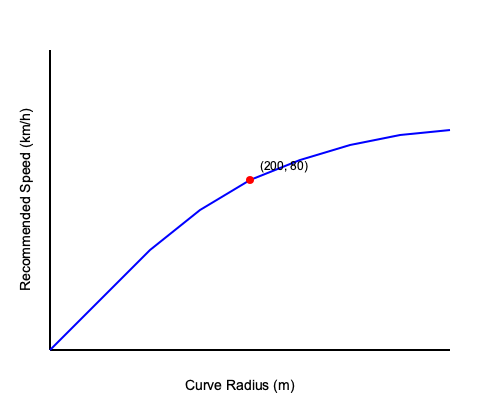Based on the graph showing the relationship between curve radius and recommended speed, what is the approximate recommended speed for a curve with a radius of 200 meters? How does this relationship demonstrate the importance of adjusting speed for different road curvatures, and what implications does this have for a professional driver focused on traffic safety? To answer this question, we need to analyze the graph and understand the relationship between curve radius and recommended speed. Let's break it down step-by-step:

1. Locate the point on the x-axis (Curve Radius) corresponding to 200 meters.
2. From this point, move vertically up to the curve on the graph.
3. The y-coordinate of this point gives us the recommended speed.
4. We can see that the point (200, 80) is marked on the graph, indicating that for a curve radius of 200 meters, the recommended speed is approximately 80 km/h.

The relationship demonstrated in the graph has several important implications for traffic safety:

1. Inverse relationship: As the curve radius increases, the recommended speed also increases, but at a decreasing rate. This shows that sharper curves (smaller radii) require significantly lower speeds for safe navigation.

2. Non-linear relationship: The curve is not a straight line, indicating that the relationship between curve radius and safe speed is complex and non-linear.

3. Rapid change at low radii: The steeper slope at the left side of the graph shows that small changes in curve radius at lower values have a more significant impact on recommended speed.

4. Plateauing effect: As the curve radius becomes very large (approaching a straight road), the recommended speed increase becomes minimal, suggesting an upper limit to safe speeds even on nearly straight roads.

For a professional driver focused on traffic safety, this graph emphasizes several key points:

1. Constant vigilance: Drivers must continually assess road geometry and adjust their speed accordingly.
2. Anticipation: Understanding this relationship allows drivers to anticipate necessary speed adjustments before entering curves.
3. Margin of safety: The graph provides a guide for maximum recommended speeds, but a safety-conscious driver may choose to drive below these limits, especially in adverse conditions.
4. Smooth driving: Gradual speed adjustments based on changing road curvature can lead to smoother, more fuel-efficient, and safer driving.
5. Risk awareness: The graph highlights the increased risk associated with sharper curves, prompting extra caution in these areas.

Understanding and applying this knowledge is crucial for maintaining safety, especially when driving larger vehicles or in challenging conditions.
Answer: 80 km/h; demonstrates inverse non-linear relationship between curve radius and safe speed, emphasizing need for constant speed adjustment and heightened caution on sharper curves. 